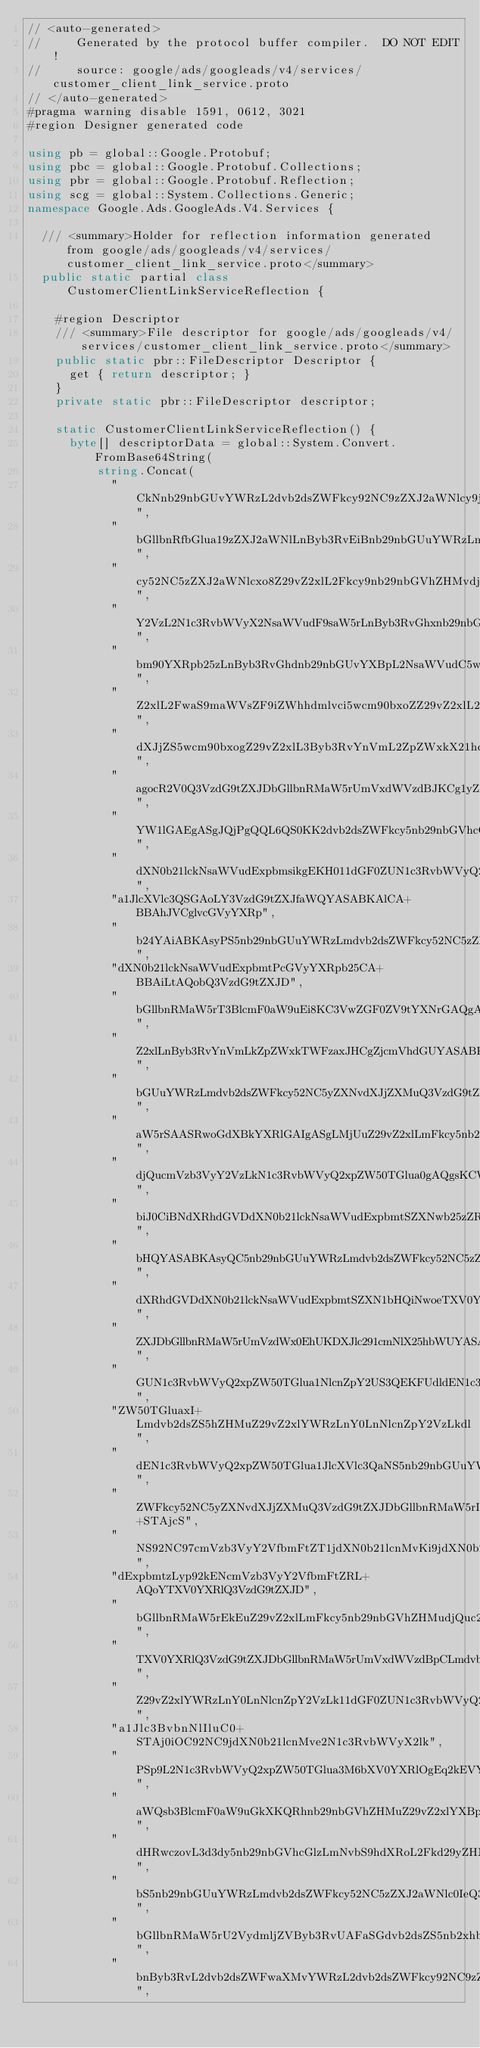<code> <loc_0><loc_0><loc_500><loc_500><_C#_>// <auto-generated>
//     Generated by the protocol buffer compiler.  DO NOT EDIT!
//     source: google/ads/googleads/v4/services/customer_client_link_service.proto
// </auto-generated>
#pragma warning disable 1591, 0612, 3021
#region Designer generated code

using pb = global::Google.Protobuf;
using pbc = global::Google.Protobuf.Collections;
using pbr = global::Google.Protobuf.Reflection;
using scg = global::System.Collections.Generic;
namespace Google.Ads.GoogleAds.V4.Services {

  /// <summary>Holder for reflection information generated from google/ads/googleads/v4/services/customer_client_link_service.proto</summary>
  public static partial class CustomerClientLinkServiceReflection {

    #region Descriptor
    /// <summary>File descriptor for google/ads/googleads/v4/services/customer_client_link_service.proto</summary>
    public static pbr::FileDescriptor Descriptor {
      get { return descriptor; }
    }
    private static pbr::FileDescriptor descriptor;

    static CustomerClientLinkServiceReflection() {
      byte[] descriptorData = global::System.Convert.FromBase64String(
          string.Concat(
            "CkNnb29nbGUvYWRzL2dvb2dsZWFkcy92NC9zZXJ2aWNlcy9jdXN0b21lcl9j",
            "bGllbnRfbGlua19zZXJ2aWNlLnByb3RvEiBnb29nbGUuYWRzLmdvb2dsZWFk",
            "cy52NC5zZXJ2aWNlcxo8Z29vZ2xlL2Fkcy9nb29nbGVhZHMvdjQvcmVzb3Vy",
            "Y2VzL2N1c3RvbWVyX2NsaWVudF9saW5rLnByb3RvGhxnb29nbGUvYXBpL2Fu",
            "bm90YXRpb25zLnByb3RvGhdnb29nbGUvYXBpL2NsaWVudC5wcm90bxofZ29v",
            "Z2xlL2FwaS9maWVsZF9iZWhhdmlvci5wcm90bxoZZ29vZ2xlL2FwaS9yZXNv",
            "dXJjZS5wcm90bxogZ29vZ2xlL3Byb3RvYnVmL2ZpZWxkX21hc2sucHJvdG8i",
            "agocR2V0Q3VzdG9tZXJDbGllbnRMaW5rUmVxdWVzdBJKCg1yZXNvdXJjZV9u",
            "YW1lGAEgASgJQjPgQQL6QS0KK2dvb2dsZWFkcy5nb29nbGVhcGlzLmNvbS9D",
            "dXN0b21lckNsaWVudExpbmsikgEKH011dGF0ZUN1c3RvbWVyQ2xpZW50TGlu",
            "a1JlcXVlc3QSGAoLY3VzdG9tZXJfaWQYASABKAlCA+BBAhJVCglvcGVyYXRp",
            "b24YAiABKAsyPS5nb29nbGUuYWRzLmdvb2dsZWFkcy52NC5zZXJ2aWNlcy5D",
            "dXN0b21lckNsaWVudExpbmtPcGVyYXRpb25CA+BBAiLtAQobQ3VzdG9tZXJD",
            "bGllbnRMaW5rT3BlcmF0aW9uEi8KC3VwZGF0ZV9tYXNrGAQgASgLMhouZ29v",
            "Z2xlLnByb3RvYnVmLkZpZWxkTWFzaxJHCgZjcmVhdGUYASABKAsyNS5nb29n",
            "bGUuYWRzLmdvb2dsZWFkcy52NC5yZXNvdXJjZXMuQ3VzdG9tZXJDbGllbnRM",
            "aW5rSAASRwoGdXBkYXRlGAIgASgLMjUuZ29vZ2xlLmFkcy5nb29nbGVhZHMu",
            "djQucmVzb3VyY2VzLkN1c3RvbWVyQ2xpZW50TGlua0gAQgsKCW9wZXJhdGlv",
            "biJ0CiBNdXRhdGVDdXN0b21lckNsaWVudExpbmtSZXNwb25zZRJQCgZyZXN1",
            "bHQYASABKAsyQC5nb29nbGUuYWRzLmdvb2dsZWFkcy52NC5zZXJ2aWNlcy5N",
            "dXRhdGVDdXN0b21lckNsaWVudExpbmtSZXN1bHQiNwoeTXV0YXRlQ3VzdG9t",
            "ZXJDbGllbnRMaW5rUmVzdWx0EhUKDXJlc291cmNlX25hbWUYASABKAkywwQK",
            "GUN1c3RvbWVyQ2xpZW50TGlua1NlcnZpY2US3QEKFUdldEN1c3RvbWVyQ2xp",
            "ZW50TGluaxI+Lmdvb2dsZS5hZHMuZ29vZ2xlYWRzLnY0LnNlcnZpY2VzLkdl",
            "dEN1c3RvbWVyQ2xpZW50TGlua1JlcXVlc3QaNS5nb29nbGUuYWRzLmdvb2ds",
            "ZWFkcy52NC5yZXNvdXJjZXMuQ3VzdG9tZXJDbGllbnRMaW5rIk2C0+STAjcS",
            "NS92NC97cmVzb3VyY2VfbmFtZT1jdXN0b21lcnMvKi9jdXN0b21lckNsaWVu",
            "dExpbmtzLyp92kENcmVzb3VyY2VfbmFtZRL+AQoYTXV0YXRlQ3VzdG9tZXJD",
            "bGllbnRMaW5rEkEuZ29vZ2xlLmFkcy5nb29nbGVhZHMudjQuc2VydmljZXMu",
            "TXV0YXRlQ3VzdG9tZXJDbGllbnRMaW5rUmVxdWVzdBpCLmdvb2dsZS5hZHMu",
            "Z29vZ2xlYWRzLnY0LnNlcnZpY2VzLk11dGF0ZUN1c3RvbWVyQ2xpZW50TGlu",
            "a1Jlc3BvbnNlIluC0+STAj0iOC92NC9jdXN0b21lcnMve2N1c3RvbWVyX2lk",
            "PSp9L2N1c3RvbWVyQ2xpZW50TGlua3M6bXV0YXRlOgEq2kEVY3VzdG9tZXJf",
            "aWQsb3BlcmF0aW9uGkXKQRhnb29nbGVhZHMuZ29vZ2xlYXBpcy5jb23SQSdo",
            "dHRwczovL3d3dy5nb29nbGVhcGlzLmNvbS9hdXRoL2Fkd29yZHNChQIKJGNv",
            "bS5nb29nbGUuYWRzLmdvb2dsZWFkcy52NC5zZXJ2aWNlc0IeQ3VzdG9tZXJD",
            "bGllbnRMaW5rU2VydmljZVByb3RvUAFaSGdvb2dsZS5nb2xhbmcub3JnL2dl",
            "bnByb3RvL2dvb2dsZWFwaXMvYWRzL2dvb2dsZWFkcy92NC9zZXJ2aWNlcztz",</code> 